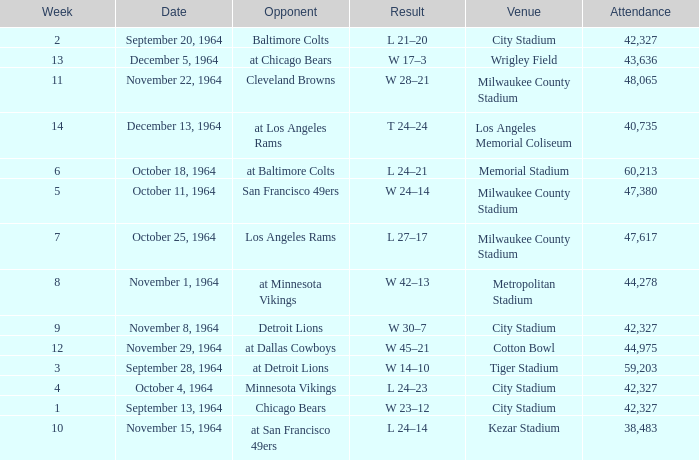What is the average week of the game on November 22, 1964 attended by 48,065? None. 